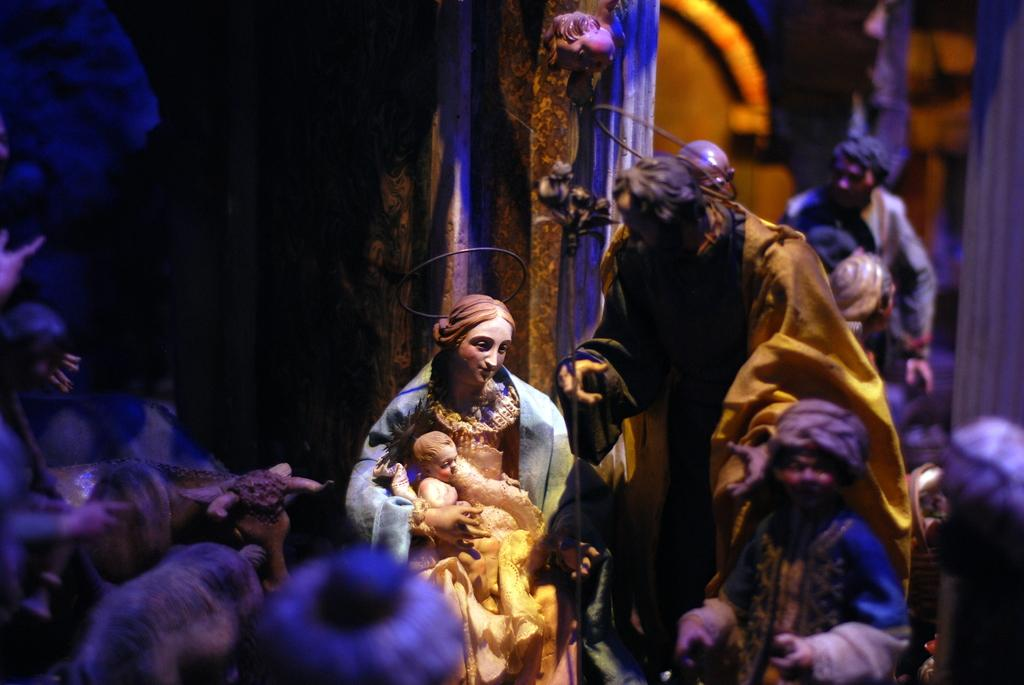What can be seen in the image? There are statues in the image. What is the color of the background in the image? The background of the image is dark. Reasoning: Let's think step by identifying the main subjects and objects in the image based on the provided facts. We then formulate questions that focus on the location and characteristics of these subjects and objects, ensuring that each question can be answered definitively with the information given. We avoid yes/no questions and ensure that the language is simple and clear. Absurd Question/Answer: Can you see anyone swinging in the image? There is no swing present in the image. What type of cemetery can be seen in the image? There is no cemetery present in the image; it features statues. How many people are breathing in the image? The concept of breathing is not relevant to the image, as it only features statues. Can you see any animals breathing in the image? There are no animals present in the image; it only features statues. 